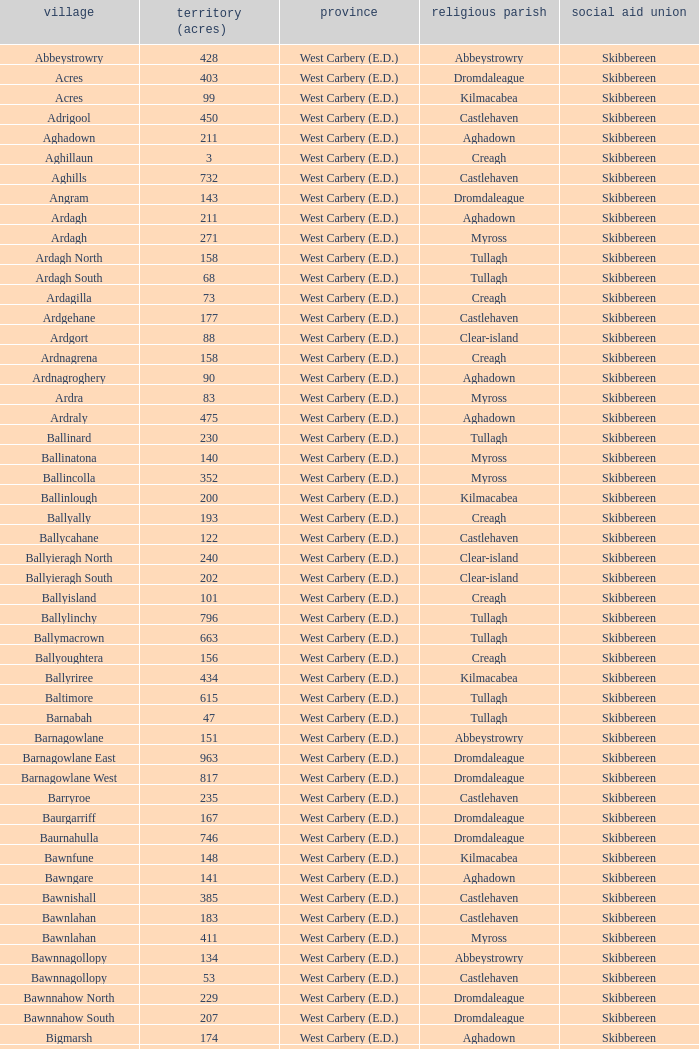What is the greatest area when the Poor Law Union is Skibbereen and the Civil Parish is Tullagh? 796.0. 